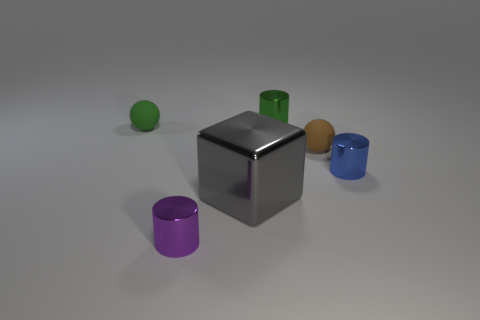Is there anything else that is the same size as the gray metallic block?
Give a very brief answer. No. Do the tiny ball right of the green matte thing and the small blue cylinder have the same material?
Give a very brief answer. No. The green rubber object has what shape?
Give a very brief answer. Sphere. There is a matte ball that is in front of the small rubber ball that is on the left side of the purple metal object; what number of purple metallic things are in front of it?
Give a very brief answer. 1. How many other objects are there of the same material as the small purple cylinder?
Provide a succinct answer. 3. What is the material of the purple cylinder that is the same size as the brown rubber thing?
Your answer should be compact. Metal. There is a tiny matte ball to the left of the large gray block; is its color the same as the metal thing behind the small brown rubber object?
Make the answer very short. Yes. Are there any small gray rubber things of the same shape as the tiny brown rubber thing?
Your answer should be compact. No. What is the shape of the brown rubber object that is the same size as the green matte object?
Your response must be concise. Sphere. How many blocks have the same color as the big thing?
Offer a terse response. 0. 